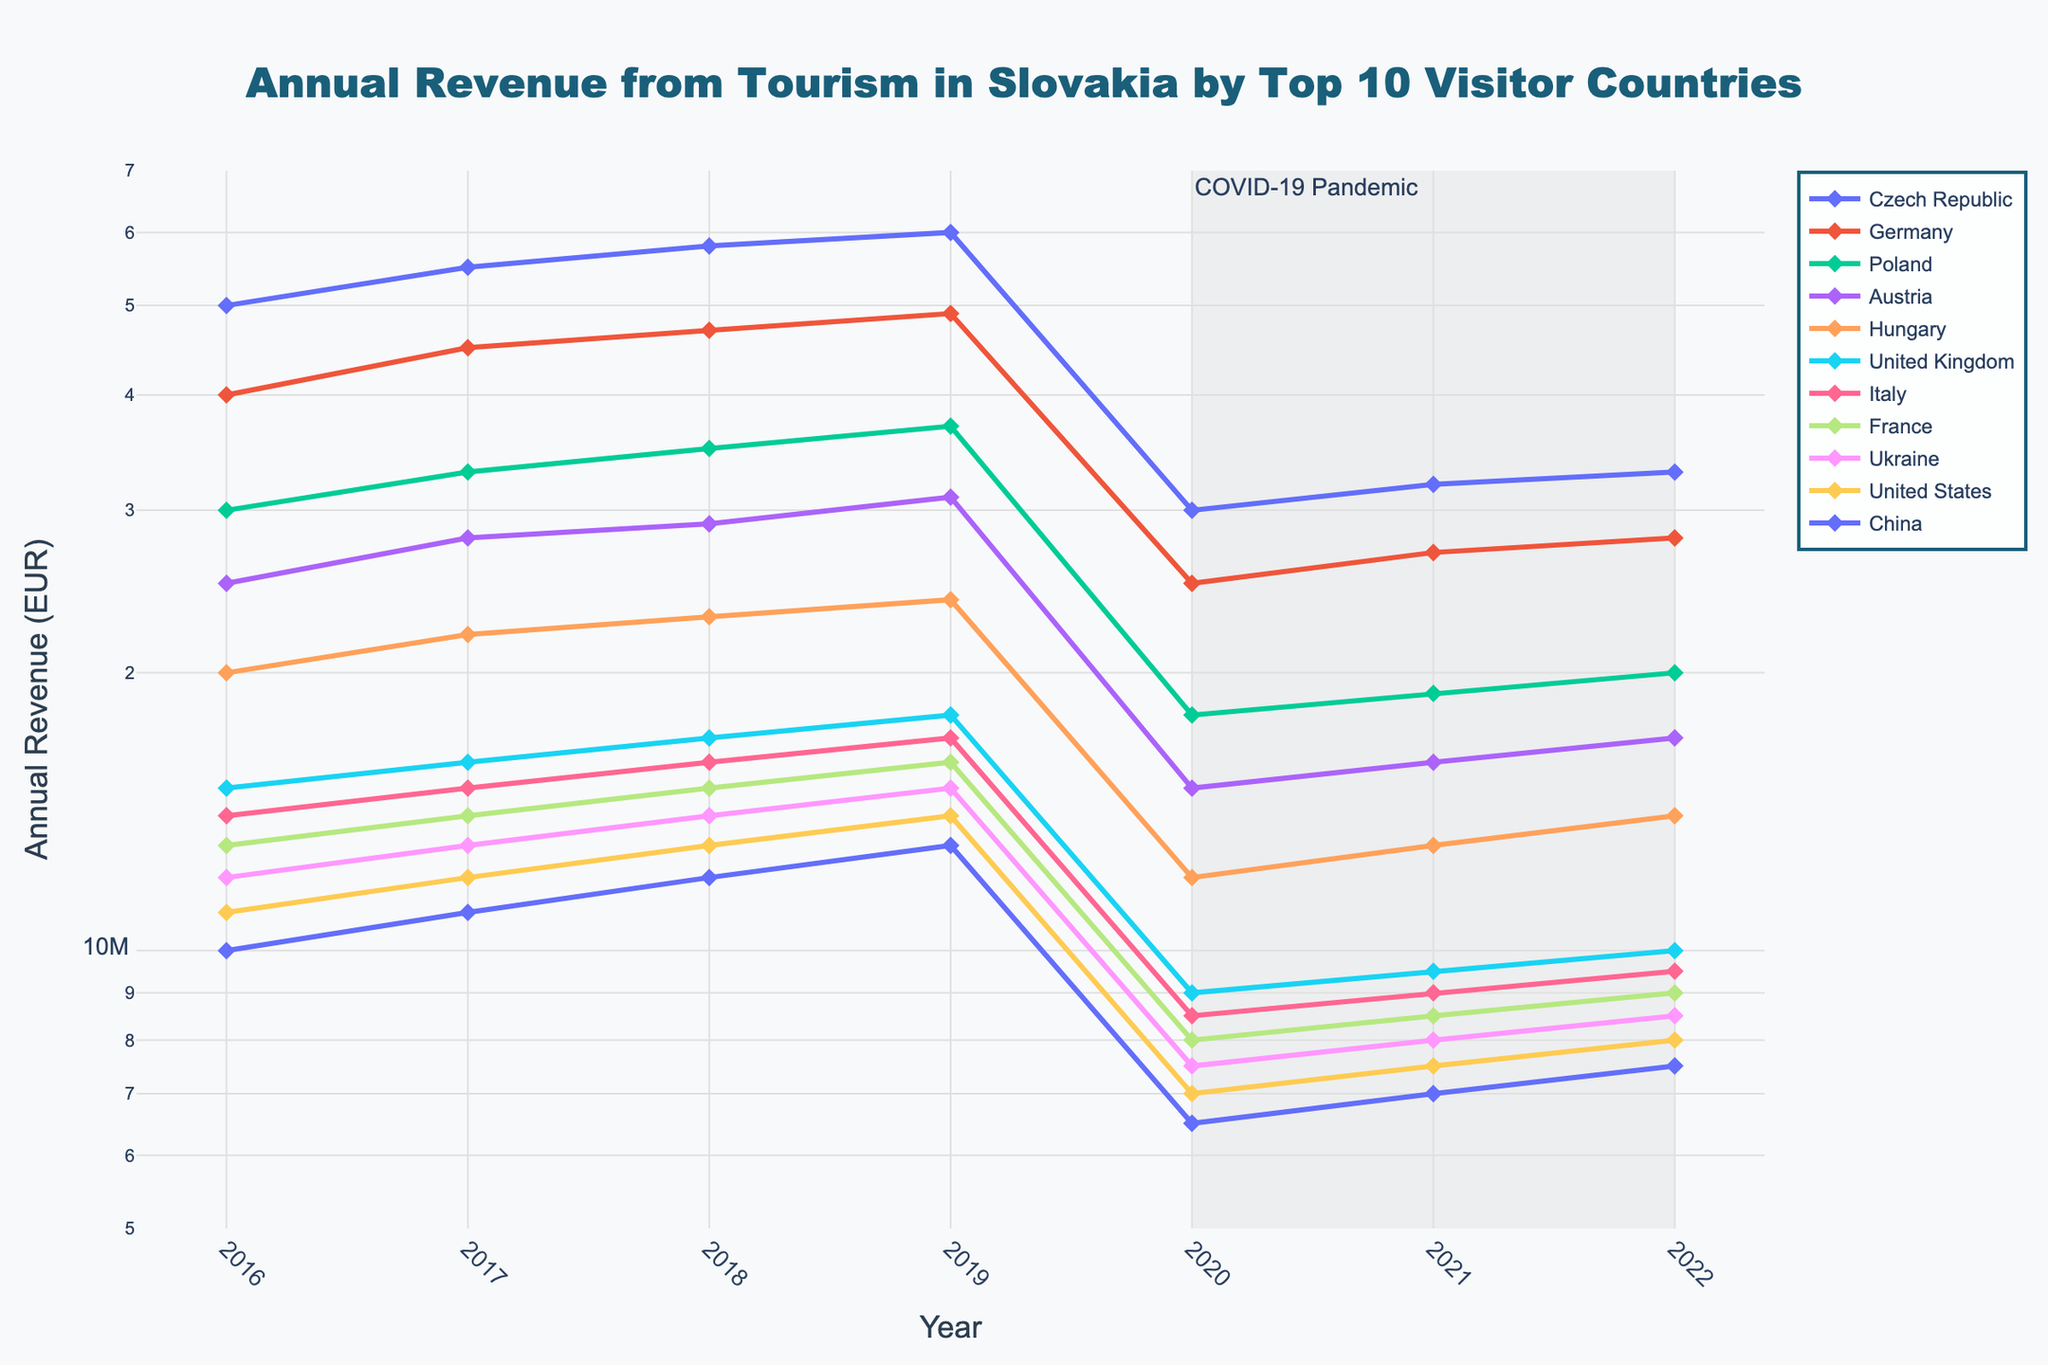What is the title of the plot? The title is typically at the top of the figure and clearly states what the figure is about.
Answer: Annual Revenue from Tourism in Slovakia by Top 10 Visitor Countries What are the years covered in the plot? The x-axis represents the years, and the plot covers from the year 2016 to 2022.
Answer: From 2016 to 2022 Which country had the highest tourism revenue in 2016? By looking at the different lines at the point corresponding to 2016 on the x-axis, we see that the Czech Republic's line is the highest.
Answer: Czech Republic How did the tourism revenue from Germany change between 2019 and 2020? We locate Germany on the legend and then find its line on the plot. By comparing height differences between 2019 and 2020 on the y-axis, we observe a significant drop in 2020.
Answer: It decreased Which country had the least decline in tourism revenue from 2019 to 2020? Comparing the lines for 2019 to 2020 for each country, the smallest drop is observed for France.
Answer: France When did the tourism revenue for Italy start recovering post-COVID-19 pandemic? By examining Italy's line, the revenue starts increasing again from 2021 to 2022.
Answer: 2021 What is the overall trend for tourism revenue from China from 2016 to 2022? China’s line shows a consistent rise until 2019, followed by a decline in 2020 and gradual recovery from 2021 to 2022.
Answer: Gradual increase, decline in 2020, then recovery Which country had consistently lower tourism revenue than the Czech Republic but higher than Ukraine? By comparing the height of the lines on the y-axis, we observe that Germany fits this criterion across all years.
Answer: Germany Which country shows the steepest decline in tourism revenue in 2020? By comparing the slopes of the lines between 2019 and 2020, Italy shows the steepest decline.
Answer: Italy 